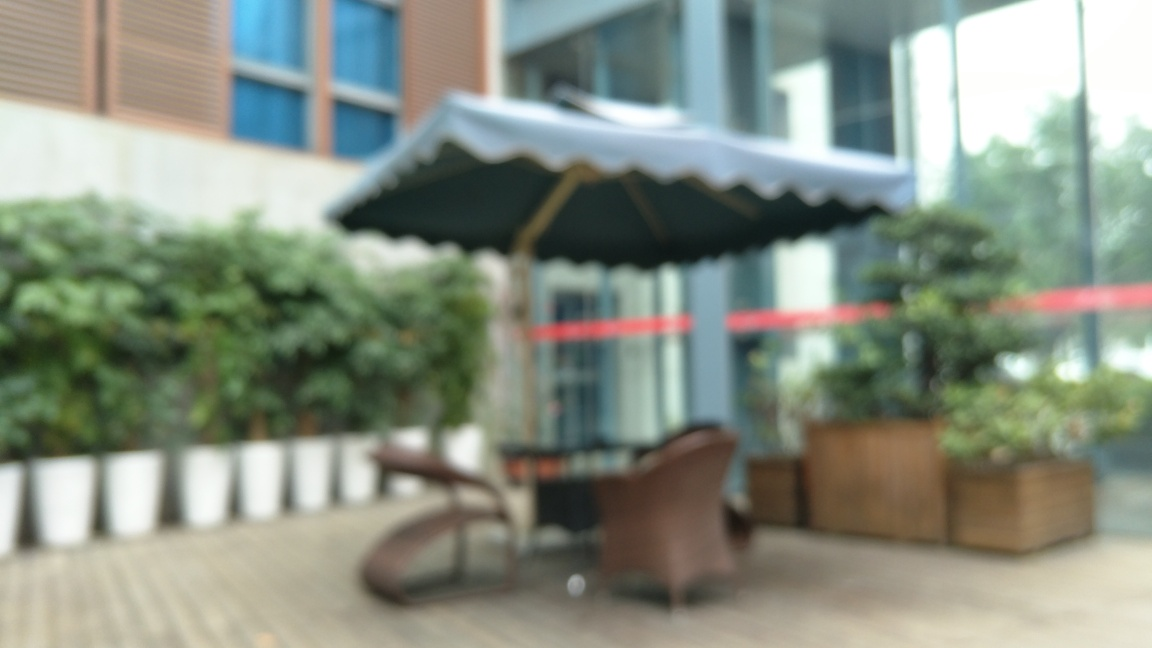Could this area be part of a commercial space or a residential area? The outdoor furniture and large potted plants hint at a communal space that could be part of a commercial setting, like a cafe or company courtyard. The blurriness of the photo limits the ability to identify specific commercial identifiers. 